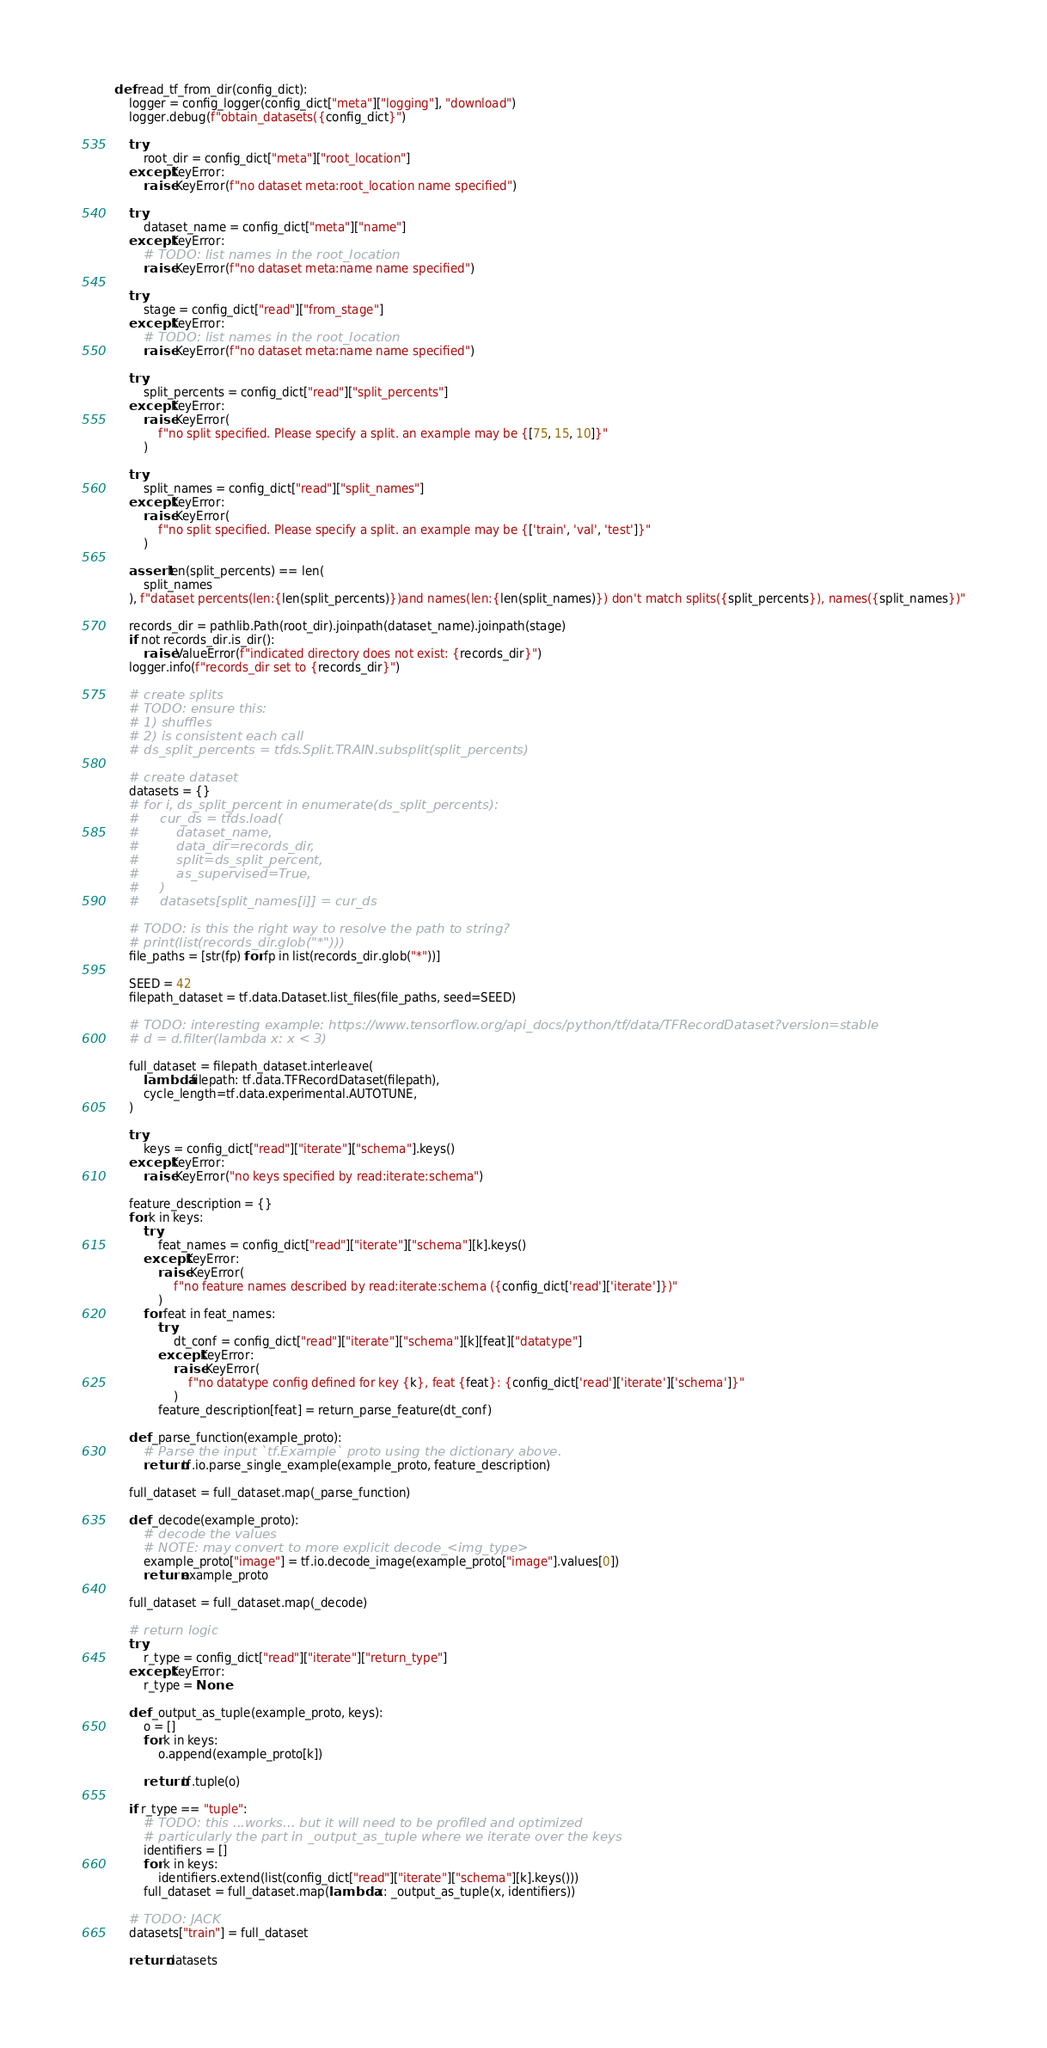<code> <loc_0><loc_0><loc_500><loc_500><_Python_>

def read_tf_from_dir(config_dict):
    logger = config_logger(config_dict["meta"]["logging"], "download")
    logger.debug(f"obtain_datasets({config_dict}")

    try:
        root_dir = config_dict["meta"]["root_location"]
    except KeyError:
        raise KeyError(f"no dataset meta:root_location name specified")

    try:
        dataset_name = config_dict["meta"]["name"]
    except KeyError:
        # TODO: list names in the root_location
        raise KeyError(f"no dataset meta:name name specified")

    try:
        stage = config_dict["read"]["from_stage"]
    except KeyError:
        # TODO: list names in the root_location
        raise KeyError(f"no dataset meta:name name specified")

    try:
        split_percents = config_dict["read"]["split_percents"]
    except KeyError:
        raise KeyError(
            f"no split specified. Please specify a split. an example may be {[75, 15, 10]}"
        )

    try:
        split_names = config_dict["read"]["split_names"]
    except KeyError:
        raise KeyError(
            f"no split specified. Please specify a split. an example may be {['train', 'val', 'test']}"
        )

    assert len(split_percents) == len(
        split_names
    ), f"dataset percents(len:{len(split_percents)})and names(len:{len(split_names)}) don't match splits({split_percents}), names({split_names})"

    records_dir = pathlib.Path(root_dir).joinpath(dataset_name).joinpath(stage)
    if not records_dir.is_dir():
        raise ValueError(f"indicated directory does not exist: {records_dir}")
    logger.info(f"records_dir set to {records_dir}")

    # create splits
    # TODO: ensure this:
    # 1) shuffles
    # 2) is consistent each call
    # ds_split_percents = tfds.Split.TRAIN.subsplit(split_percents)

    # create dataset
    datasets = {}
    # for i, ds_split_percent in enumerate(ds_split_percents):
    #     cur_ds = tfds.load(
    #         dataset_name,
    #         data_dir=records_dir,
    #         split=ds_split_percent,
    #         as_supervised=True,
    #     )
    #     datasets[split_names[i]] = cur_ds

    # TODO: is this the right way to resolve the path to string?
    # print(list(records_dir.glob("*")))
    file_paths = [str(fp) for fp in list(records_dir.glob("*"))]

    SEED = 42
    filepath_dataset = tf.data.Dataset.list_files(file_paths, seed=SEED)

    # TODO: interesting example: https://www.tensorflow.org/api_docs/python/tf/data/TFRecordDataset?version=stable
    # d = d.filter(lambda x: x < 3)

    full_dataset = filepath_dataset.interleave(
        lambda filepath: tf.data.TFRecordDataset(filepath),
        cycle_length=tf.data.experimental.AUTOTUNE,
    )

    try:
        keys = config_dict["read"]["iterate"]["schema"].keys()
    except KeyError:
        raise KeyError("no keys specified by read:iterate:schema")

    feature_description = {}
    for k in keys:
        try:
            feat_names = config_dict["read"]["iterate"]["schema"][k].keys()
        except KeyError:
            raise KeyError(
                f"no feature names described by read:iterate:schema ({config_dict['read']['iterate']})"
            )
        for feat in feat_names:
            try:
                dt_conf = config_dict["read"]["iterate"]["schema"][k][feat]["datatype"]
            except KeyError:
                raise KeyError(
                    f"no datatype config defined for key {k}, feat {feat}: {config_dict['read']['iterate']['schema']}"
                )
            feature_description[feat] = return_parse_feature(dt_conf)

    def _parse_function(example_proto):
        # Parse the input `tf.Example` proto using the dictionary above.
        return tf.io.parse_single_example(example_proto, feature_description)

    full_dataset = full_dataset.map(_parse_function)

    def _decode(example_proto):
        # decode the values
        # NOTE: may convert to more explicit decode_<img_type>
        example_proto["image"] = tf.io.decode_image(example_proto["image"].values[0])
        return example_proto

    full_dataset = full_dataset.map(_decode)

    # return logic
    try:
        r_type = config_dict["read"]["iterate"]["return_type"]
    except KeyError:
        r_type = None

    def _output_as_tuple(example_proto, keys):
        o = []
        for k in keys:
            o.append(example_proto[k])

        return tf.tuple(o)

    if r_type == "tuple":
        # TODO: this ...works... but it will need to be profiled and optimized
        # particularly the part in _output_as_tuple where we iterate over the keys
        identifiers = []
        for k in keys:
            identifiers.extend(list(config_dict["read"]["iterate"]["schema"][k].keys()))
        full_dataset = full_dataset.map(lambda x: _output_as_tuple(x, identifiers))

    # TODO: JACK
    datasets["train"] = full_dataset

    return datasets

</code> 